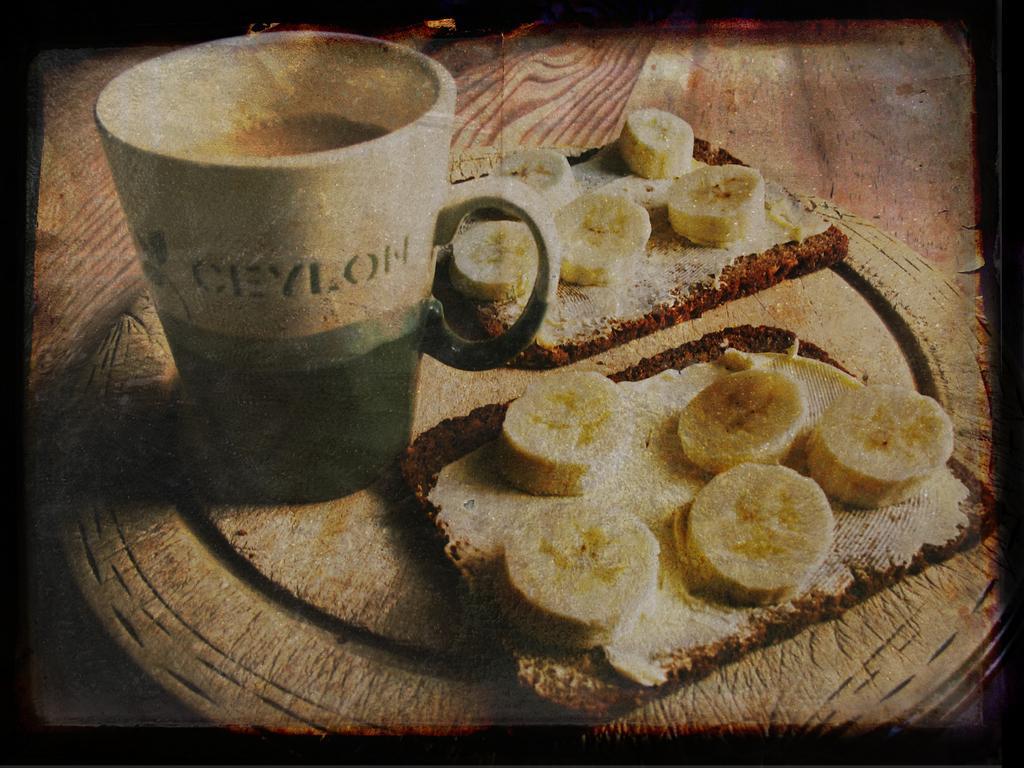Describe this image in one or two sentences. This is an edited image. In this image I can see a wooden tray which consists of a tea mug, bread and banana slices. 